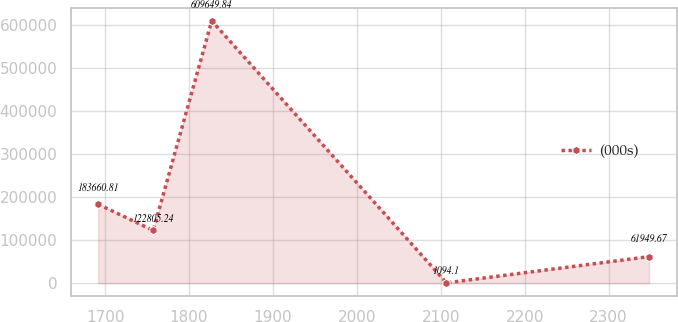<chart> <loc_0><loc_0><loc_500><loc_500><line_chart><ecel><fcel>(000s)<nl><fcel>1691.68<fcel>183661<nl><fcel>1757.33<fcel>122805<nl><fcel>1827.06<fcel>609650<nl><fcel>2106.78<fcel>1094.1<nl><fcel>2348.18<fcel>61949.7<nl></chart> 